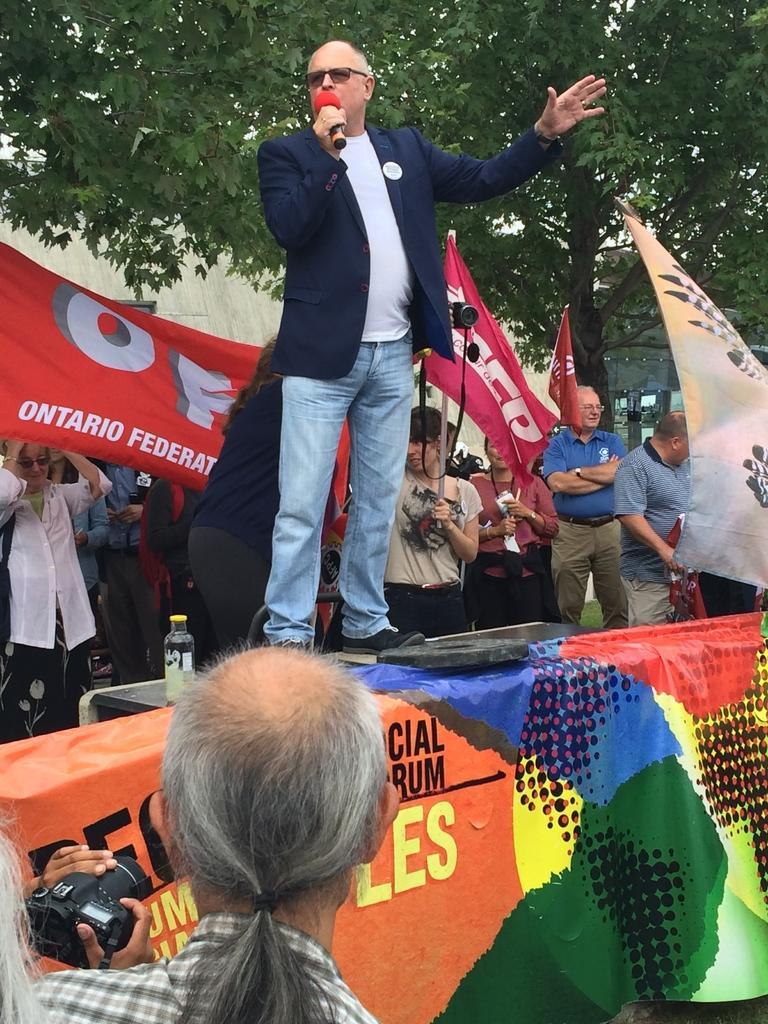Describe this image in one or two sentences. In this image there is a person standing on a platform is speaking in a mic, behind the person there are a few people standing and holding banners and flags, behind them there are trees and buildings, in front of the person there are a few people standing and holding cameras, on the platform there is a banner. 